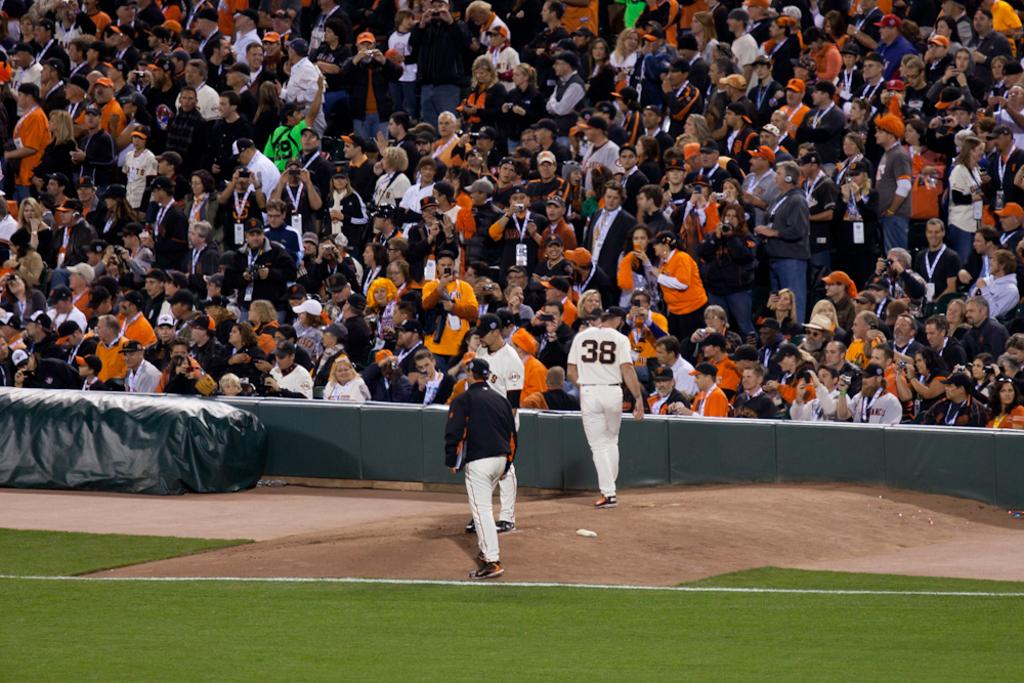<image>
Render a clear and concise summary of the photo. sportsmen in front of a crowd, one of whom is wearing a number 38 shirt. 